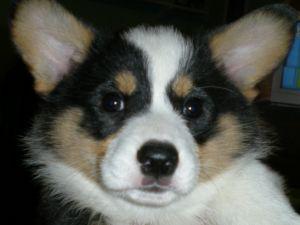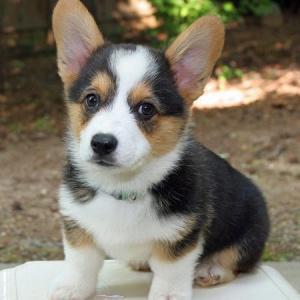The first image is the image on the left, the second image is the image on the right. Analyze the images presented: Is the assertion "One puppy has their tongue out." valid? Answer yes or no. No. The first image is the image on the left, the second image is the image on the right. For the images shown, is this caption "A small dog with its tongue hanging out is on a light colored chair." true? Answer yes or no. No. 